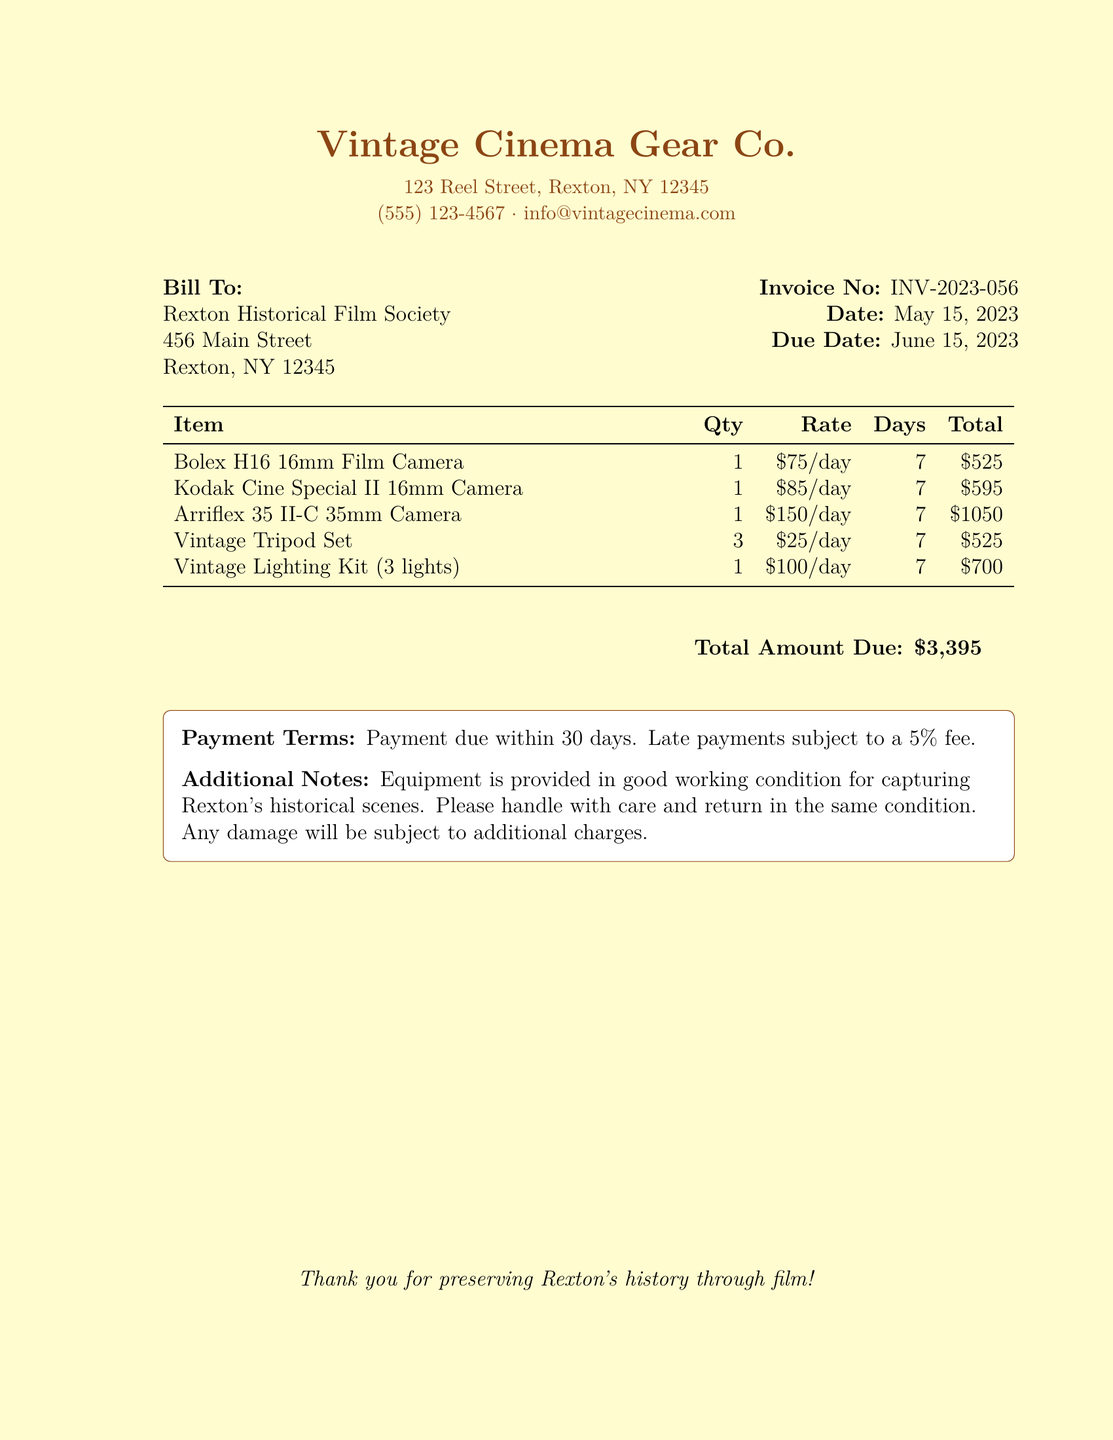What is the invoice number? The invoice number is listed in the document as part of the billing information.
Answer: INV-2023-056 What is the total amount due? The total amount due is calculated from the sum of all items listed in the invoice.
Answer: $3,395 How many days was the equipment rented? The rental period for the equipment is specified in the table of items.
Answer: 7 What is the rate for the Kodak Cine Special II 16mm Camera? The rate for this specific camera is mentioned in the itemized list.
Answer: $85/day Who is the bill recipient? The recipient of the bill is indicated at the beginning of the document.
Answer: Rexton Historical Film Society What equipment has the highest rental rate per day? By comparing the rates listed in the document, we can identify the item with the highest cost.
Answer: Arriflex 35 II-C 35mm Camera What are the payment terms stated in the document? The payment terms are described in a dedicated section toward the end of the document.
Answer: Payment due within 30 days What color is the background of the invoice? The document uses a specific color scheme for its background.
Answer: Vintage cream What should be done with the equipment after use? Instructions for the handling and return of the equipment are provided in the notes.
Answer: Return in the same condition 